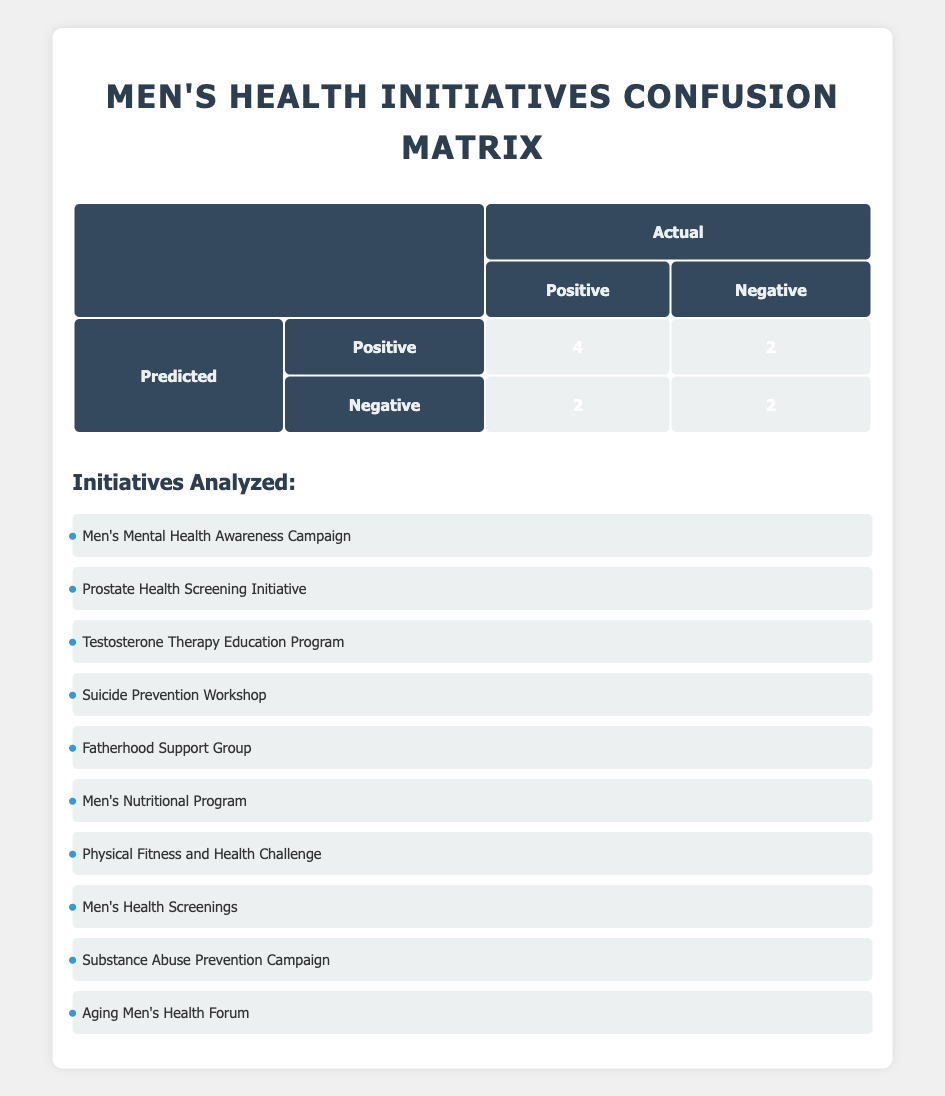What is the total number of true positives in the confusion matrix? The confusion matrix indicates true positives as those initiatives where both predicted and actual results are "Positive". In the table, there are 4 true positives: "Men's Mental Health Awareness Campaign," "Suicide Prevention Workshop," "Men's Nutritional Program," and "Men's Health Screenings."
Answer: 4 How many initiatives were predicted to be positive but were actually negative? This refers to false positives, which occur when the prediction is positive but the actual result is negative. In the table, there are 2 such cases: "Prostate Health Screening Initiative" and "Substance Abuse Prevention Campaign."
Answer: 2 Is it true that all initiatives predicted as negative were actually negative? To determine this, we check the initiatives under the "Negative" prediction that were also negative in reality. There are 2 such initiatives: "Testosterone Therapy Education Program" and "Physical Fitness and Health Challenge." However, "Fatherhood Support Group" and "Aging Men's Health Forum" were predicted negative but were actually positive, so it is false.
Answer: No What percentage of the total predictions were true negatives? First, we find the total number of predictions, which is 10. Then, we identify the true negatives, which are 2 in the table: "Physical Fitness and Health Challenge" and the other negative prediction. To get the percentage, we calculate (2 true negatives / 10 total predictions) * 100 = 20%.
Answer: 20% How many more positive predictions were correct than incorrect? To find this, we compare true positives and false positives. From the table, there are 4 true positives and 2 false positives, so the difference is 4 - 2 = 2.
Answer: 2 What is the total number of false negatives in the confusion matrix? False negatives occur when the prediction is "Negative" but the actual result is "Positive." In the table, there are 2 instances: "Fatherhood Support Group" and "Aging Men's Health Forum." Summing these gives us a total of 2.
Answer: 2 Which initiative had a correct prediction while being among the initiatives that were seen as successful? Specific initiatives that yielded positive results include "Men's Mental Health Awareness Campaign," "Suicide Prevention Workshop," "Men's Nutritional Program," and "Men's Health Screenings." All were also predicted as positive, indicating they are both successful and correctly predicted.
Answer: 4 What is the ratio of true positives to false negatives? True positives amount to 4, while false negatives total 2 based on the table. Thus, the ratio of true positives to false negatives is 4:2, which simplifies to 2:1.
Answer: 2:1 